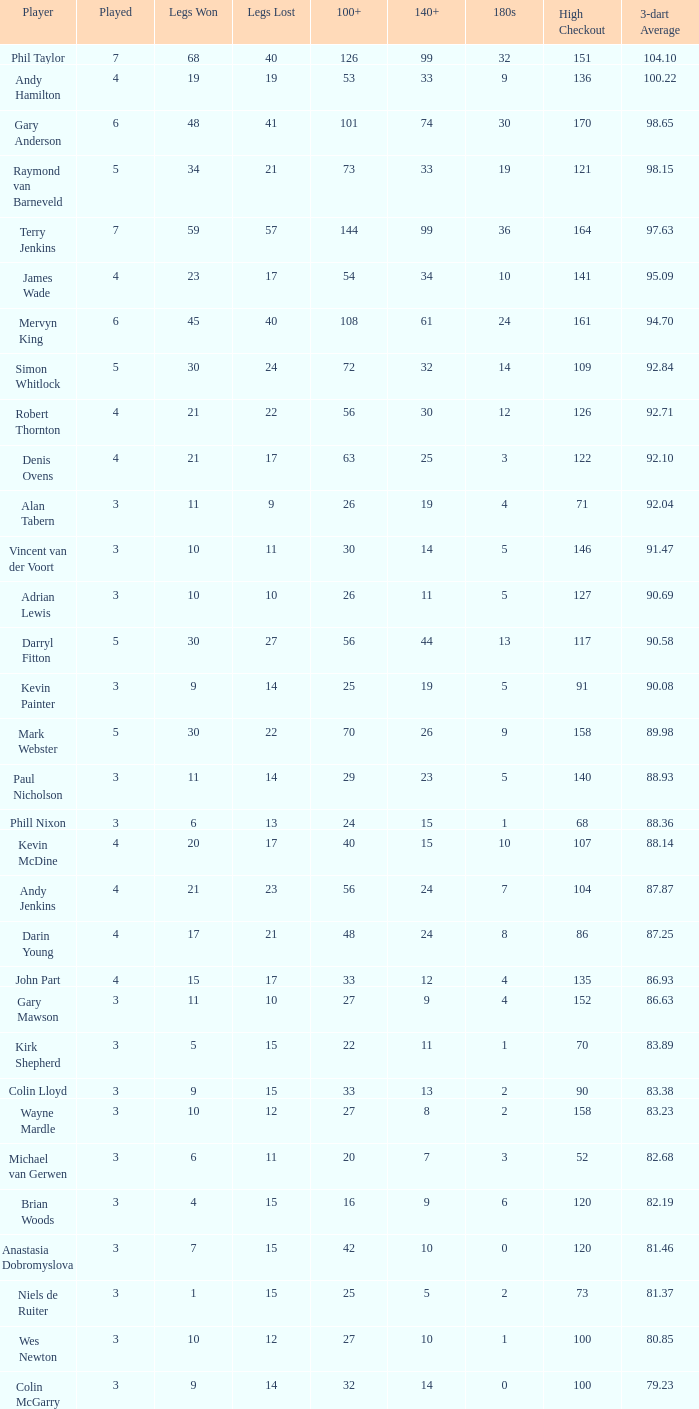36? None. 